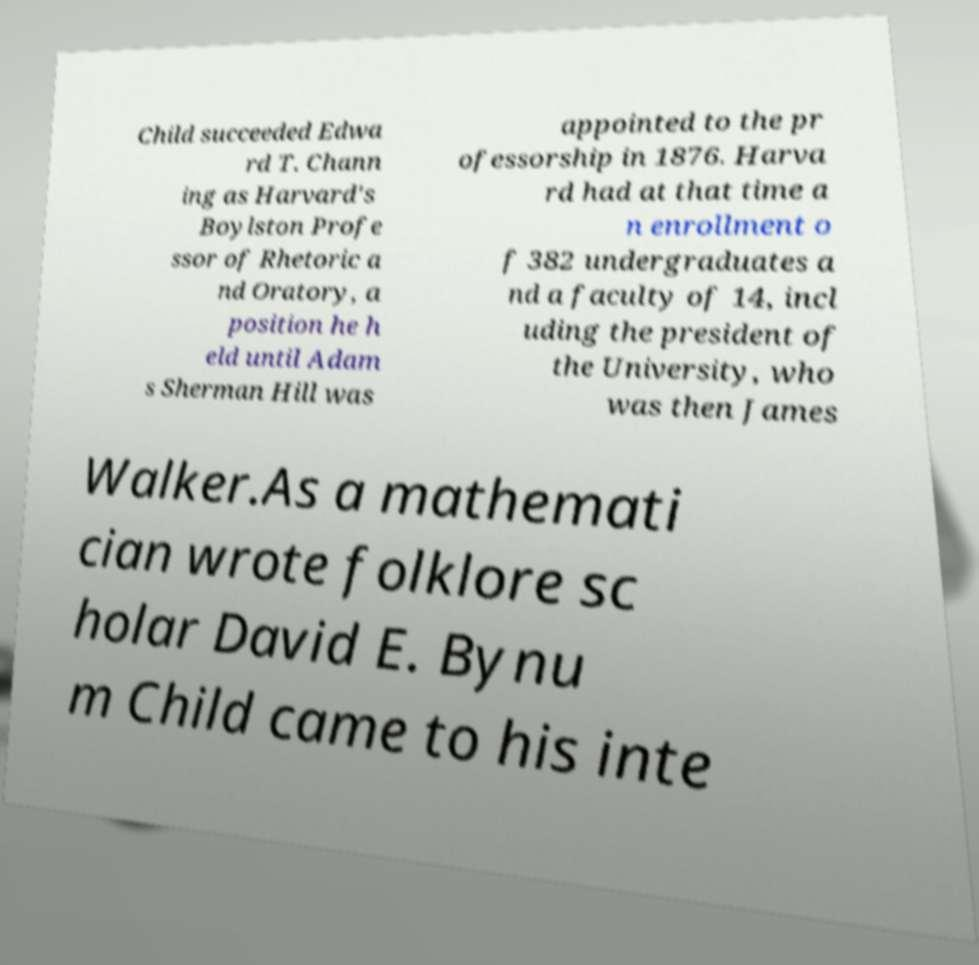Can you read and provide the text displayed in the image?This photo seems to have some interesting text. Can you extract and type it out for me? Child succeeded Edwa rd T. Chann ing as Harvard's Boylston Profe ssor of Rhetoric a nd Oratory, a position he h eld until Adam s Sherman Hill was appointed to the pr ofessorship in 1876. Harva rd had at that time a n enrollment o f 382 undergraduates a nd a faculty of 14, incl uding the president of the University, who was then James Walker.As a mathemati cian wrote folklore sc holar David E. Bynu m Child came to his inte 